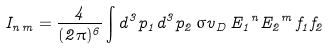Convert formula to latex. <formula><loc_0><loc_0><loc_500><loc_500>I _ { n \, m } = \frac { 4 } { ( 2 \pi ) ^ { 6 } } \int d ^ { 3 } p _ { 1 } d ^ { 3 } p _ { 2 } \, { \sigma v } _ { D } \, { E _ { 1 } } ^ { n } { E _ { 2 } } ^ { m } \, f _ { 1 } f _ { 2 }</formula> 